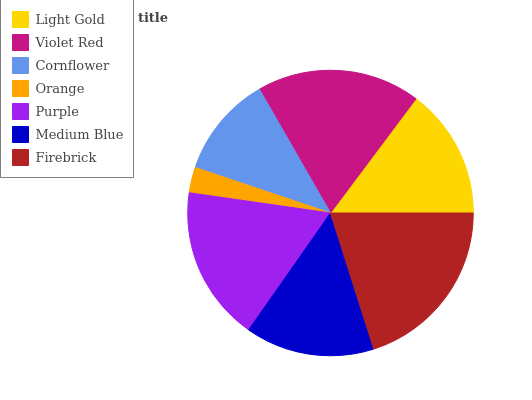Is Orange the minimum?
Answer yes or no. Yes. Is Firebrick the maximum?
Answer yes or no. Yes. Is Violet Red the minimum?
Answer yes or no. No. Is Violet Red the maximum?
Answer yes or no. No. Is Violet Red greater than Light Gold?
Answer yes or no. Yes. Is Light Gold less than Violet Red?
Answer yes or no. Yes. Is Light Gold greater than Violet Red?
Answer yes or no. No. Is Violet Red less than Light Gold?
Answer yes or no. No. Is Light Gold the high median?
Answer yes or no. Yes. Is Light Gold the low median?
Answer yes or no. Yes. Is Purple the high median?
Answer yes or no. No. Is Violet Red the low median?
Answer yes or no. No. 